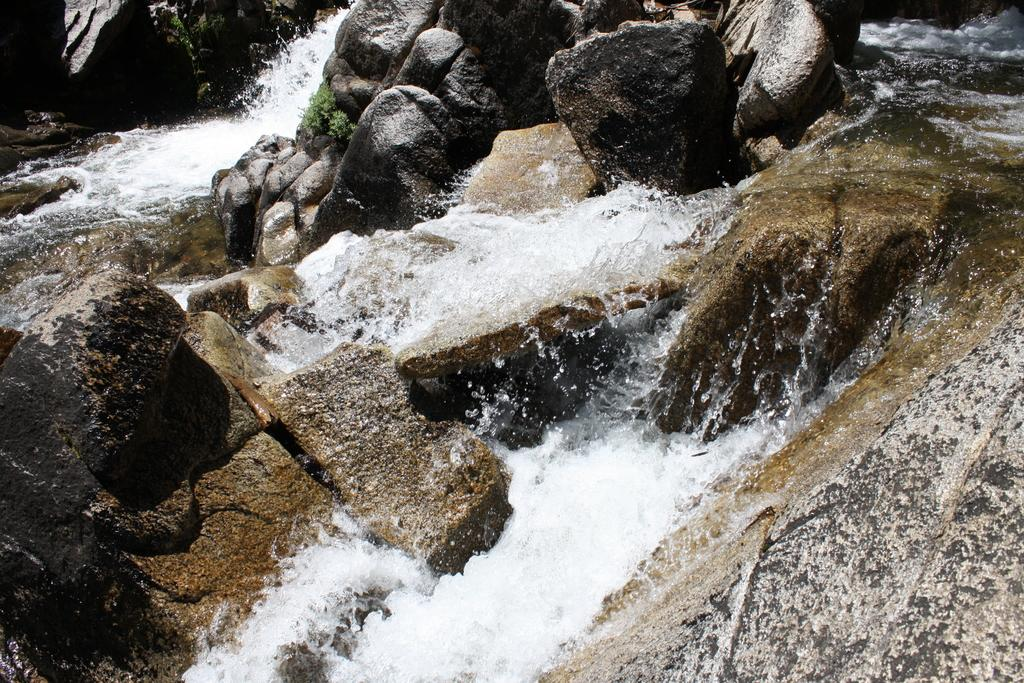What is the main feature in the center of the image? There is water in the center of the image. What else can be seen in the image besides the water? Rocks are present in the image. Is there any vegetation visible in the image? Yes, there is a plant at the top of the image. What type of machine can be seen operating in the water in the image? There is no machine present in the image; it only features water, rocks, and a plant. 